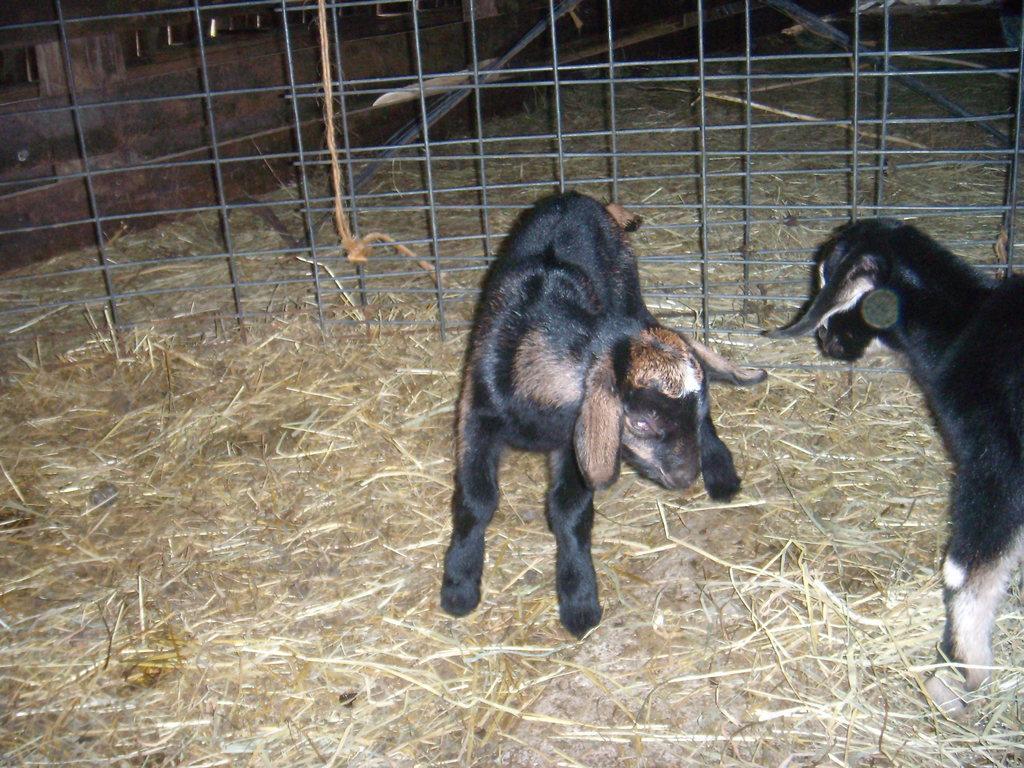Describe this image in one or two sentences. In the image we can see there is a dry grass on the ground and there are two black colour baby goats. Behind the baby goats there is a fencing which is of iron. 